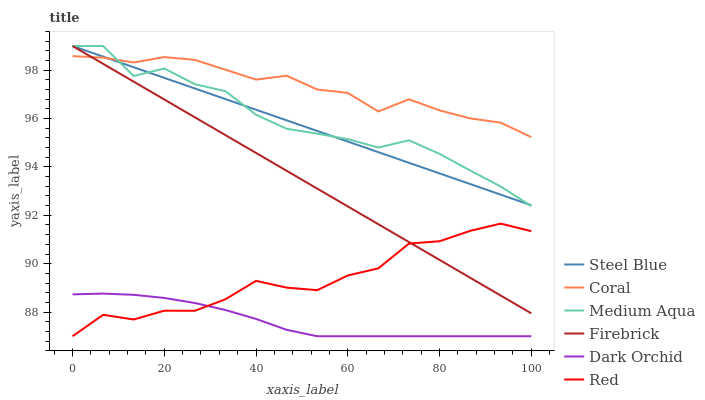Does Dark Orchid have the minimum area under the curve?
Answer yes or no. Yes. Does Coral have the maximum area under the curve?
Answer yes or no. Yes. Does Steel Blue have the minimum area under the curve?
Answer yes or no. No. Does Steel Blue have the maximum area under the curve?
Answer yes or no. No. Is Firebrick the smoothest?
Answer yes or no. Yes. Is Red the roughest?
Answer yes or no. Yes. Is Steel Blue the smoothest?
Answer yes or no. No. Is Steel Blue the roughest?
Answer yes or no. No. Does Steel Blue have the lowest value?
Answer yes or no. No. Does Medium Aqua have the highest value?
Answer yes or no. Yes. Does Dark Orchid have the highest value?
Answer yes or no. No. Is Red less than Coral?
Answer yes or no. Yes. Is Firebrick greater than Dark Orchid?
Answer yes or no. Yes. Does Red intersect Firebrick?
Answer yes or no. Yes. Is Red less than Firebrick?
Answer yes or no. No. Is Red greater than Firebrick?
Answer yes or no. No. Does Red intersect Coral?
Answer yes or no. No. 